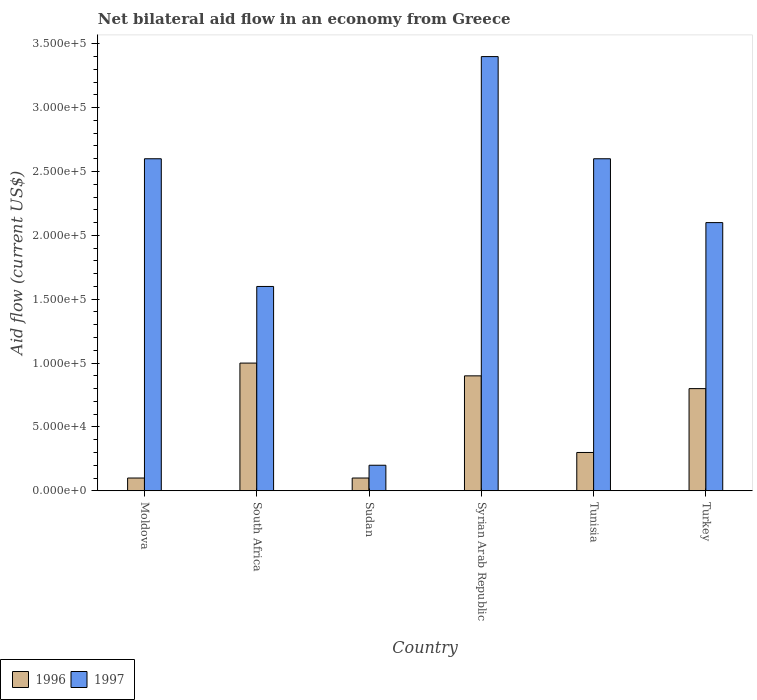How many groups of bars are there?
Your response must be concise. 6. Are the number of bars per tick equal to the number of legend labels?
Keep it short and to the point. Yes. Are the number of bars on each tick of the X-axis equal?
Ensure brevity in your answer.  Yes. How many bars are there on the 3rd tick from the left?
Your answer should be compact. 2. What is the label of the 4th group of bars from the left?
Ensure brevity in your answer.  Syrian Arab Republic. In how many cases, is the number of bars for a given country not equal to the number of legend labels?
Your answer should be compact. 0. In which country was the net bilateral aid flow in 1997 maximum?
Make the answer very short. Syrian Arab Republic. In which country was the net bilateral aid flow in 1997 minimum?
Provide a succinct answer. Sudan. What is the total net bilateral aid flow in 1996 in the graph?
Provide a short and direct response. 3.20e+05. What is the average net bilateral aid flow in 1997 per country?
Offer a terse response. 2.08e+05. In how many countries, is the net bilateral aid flow in 1996 greater than 130000 US$?
Offer a terse response. 0. What is the ratio of the net bilateral aid flow in 1996 in Sudan to that in Tunisia?
Give a very brief answer. 0.33. Is the net bilateral aid flow in 1996 in Sudan less than that in Turkey?
Offer a very short reply. Yes. Is the difference between the net bilateral aid flow in 1996 in South Africa and Syrian Arab Republic greater than the difference between the net bilateral aid flow in 1997 in South Africa and Syrian Arab Republic?
Provide a short and direct response. Yes. What is the difference between the highest and the lowest net bilateral aid flow in 1997?
Keep it short and to the point. 3.20e+05. In how many countries, is the net bilateral aid flow in 1997 greater than the average net bilateral aid flow in 1997 taken over all countries?
Give a very brief answer. 4. Is the sum of the net bilateral aid flow in 1996 in South Africa and Sudan greater than the maximum net bilateral aid flow in 1997 across all countries?
Your answer should be very brief. No. What does the 2nd bar from the left in Moldova represents?
Provide a succinct answer. 1997. How many bars are there?
Your answer should be very brief. 12. Are all the bars in the graph horizontal?
Provide a short and direct response. No. Does the graph contain any zero values?
Your answer should be very brief. No. What is the title of the graph?
Offer a terse response. Net bilateral aid flow in an economy from Greece. Does "2010" appear as one of the legend labels in the graph?
Your response must be concise. No. What is the label or title of the X-axis?
Your response must be concise. Country. What is the label or title of the Y-axis?
Your answer should be compact. Aid flow (current US$). What is the Aid flow (current US$) in 1997 in Moldova?
Your answer should be very brief. 2.60e+05. What is the Aid flow (current US$) in 1997 in Syrian Arab Republic?
Your response must be concise. 3.40e+05. What is the Aid flow (current US$) in 1996 in Tunisia?
Ensure brevity in your answer.  3.00e+04. Across all countries, what is the maximum Aid flow (current US$) in 1996?
Make the answer very short. 1.00e+05. What is the total Aid flow (current US$) of 1997 in the graph?
Provide a succinct answer. 1.25e+06. What is the difference between the Aid flow (current US$) in 1996 in Moldova and that in South Africa?
Make the answer very short. -9.00e+04. What is the difference between the Aid flow (current US$) of 1997 in Moldova and that in Sudan?
Ensure brevity in your answer.  2.40e+05. What is the difference between the Aid flow (current US$) of 1996 in Moldova and that in Syrian Arab Republic?
Make the answer very short. -8.00e+04. What is the difference between the Aid flow (current US$) in 1997 in Moldova and that in Syrian Arab Republic?
Provide a succinct answer. -8.00e+04. What is the difference between the Aid flow (current US$) in 1997 in Moldova and that in Tunisia?
Offer a very short reply. 0. What is the difference between the Aid flow (current US$) in 1996 in Moldova and that in Turkey?
Make the answer very short. -7.00e+04. What is the difference between the Aid flow (current US$) in 1996 in South Africa and that in Sudan?
Ensure brevity in your answer.  9.00e+04. What is the difference between the Aid flow (current US$) in 1996 in South Africa and that in Syrian Arab Republic?
Keep it short and to the point. 10000. What is the difference between the Aid flow (current US$) in 1997 in South Africa and that in Syrian Arab Republic?
Provide a succinct answer. -1.80e+05. What is the difference between the Aid flow (current US$) of 1997 in South Africa and that in Turkey?
Your answer should be very brief. -5.00e+04. What is the difference between the Aid flow (current US$) of 1996 in Sudan and that in Syrian Arab Republic?
Provide a succinct answer. -8.00e+04. What is the difference between the Aid flow (current US$) in 1997 in Sudan and that in Syrian Arab Republic?
Offer a very short reply. -3.20e+05. What is the difference between the Aid flow (current US$) in 1996 in Sudan and that in Tunisia?
Provide a short and direct response. -2.00e+04. What is the difference between the Aid flow (current US$) in 1996 in Sudan and that in Turkey?
Keep it short and to the point. -7.00e+04. What is the difference between the Aid flow (current US$) of 1996 in Syrian Arab Republic and that in Tunisia?
Make the answer very short. 6.00e+04. What is the difference between the Aid flow (current US$) in 1997 in Syrian Arab Republic and that in Tunisia?
Offer a terse response. 8.00e+04. What is the difference between the Aid flow (current US$) in 1997 in Syrian Arab Republic and that in Turkey?
Offer a very short reply. 1.30e+05. What is the difference between the Aid flow (current US$) in 1996 in Moldova and the Aid flow (current US$) in 1997 in Sudan?
Make the answer very short. -10000. What is the difference between the Aid flow (current US$) of 1996 in Moldova and the Aid flow (current US$) of 1997 in Syrian Arab Republic?
Give a very brief answer. -3.30e+05. What is the difference between the Aid flow (current US$) of 1996 in Moldova and the Aid flow (current US$) of 1997 in Tunisia?
Make the answer very short. -2.50e+05. What is the difference between the Aid flow (current US$) in 1996 in Moldova and the Aid flow (current US$) in 1997 in Turkey?
Your answer should be compact. -2.00e+05. What is the difference between the Aid flow (current US$) in 1996 in South Africa and the Aid flow (current US$) in 1997 in Syrian Arab Republic?
Your answer should be compact. -2.40e+05. What is the difference between the Aid flow (current US$) of 1996 in South Africa and the Aid flow (current US$) of 1997 in Tunisia?
Give a very brief answer. -1.60e+05. What is the difference between the Aid flow (current US$) of 1996 in Sudan and the Aid flow (current US$) of 1997 in Syrian Arab Republic?
Give a very brief answer. -3.30e+05. What is the difference between the Aid flow (current US$) in 1996 in Sudan and the Aid flow (current US$) in 1997 in Tunisia?
Give a very brief answer. -2.50e+05. What is the difference between the Aid flow (current US$) of 1996 in Sudan and the Aid flow (current US$) of 1997 in Turkey?
Give a very brief answer. -2.00e+05. What is the difference between the Aid flow (current US$) in 1996 in Syrian Arab Republic and the Aid flow (current US$) in 1997 in Tunisia?
Make the answer very short. -1.70e+05. What is the difference between the Aid flow (current US$) of 1996 in Tunisia and the Aid flow (current US$) of 1997 in Turkey?
Ensure brevity in your answer.  -1.80e+05. What is the average Aid flow (current US$) in 1996 per country?
Keep it short and to the point. 5.33e+04. What is the average Aid flow (current US$) of 1997 per country?
Offer a very short reply. 2.08e+05. What is the difference between the Aid flow (current US$) of 1996 and Aid flow (current US$) of 1997 in South Africa?
Your answer should be very brief. -6.00e+04. What is the difference between the Aid flow (current US$) of 1996 and Aid flow (current US$) of 1997 in Sudan?
Ensure brevity in your answer.  -10000. What is the difference between the Aid flow (current US$) of 1996 and Aid flow (current US$) of 1997 in Tunisia?
Your response must be concise. -2.30e+05. What is the difference between the Aid flow (current US$) of 1996 and Aid flow (current US$) of 1997 in Turkey?
Give a very brief answer. -1.30e+05. What is the ratio of the Aid flow (current US$) in 1996 in Moldova to that in South Africa?
Your answer should be very brief. 0.1. What is the ratio of the Aid flow (current US$) in 1997 in Moldova to that in South Africa?
Your answer should be very brief. 1.62. What is the ratio of the Aid flow (current US$) in 1997 in Moldova to that in Syrian Arab Republic?
Make the answer very short. 0.76. What is the ratio of the Aid flow (current US$) in 1996 in Moldova to that in Tunisia?
Give a very brief answer. 0.33. What is the ratio of the Aid flow (current US$) of 1997 in Moldova to that in Tunisia?
Ensure brevity in your answer.  1. What is the ratio of the Aid flow (current US$) of 1996 in Moldova to that in Turkey?
Ensure brevity in your answer.  0.12. What is the ratio of the Aid flow (current US$) in 1997 in Moldova to that in Turkey?
Offer a very short reply. 1.24. What is the ratio of the Aid flow (current US$) of 1996 in South Africa to that in Syrian Arab Republic?
Provide a succinct answer. 1.11. What is the ratio of the Aid flow (current US$) of 1997 in South Africa to that in Syrian Arab Republic?
Give a very brief answer. 0.47. What is the ratio of the Aid flow (current US$) in 1997 in South Africa to that in Tunisia?
Ensure brevity in your answer.  0.62. What is the ratio of the Aid flow (current US$) in 1996 in South Africa to that in Turkey?
Your answer should be very brief. 1.25. What is the ratio of the Aid flow (current US$) of 1997 in South Africa to that in Turkey?
Your answer should be compact. 0.76. What is the ratio of the Aid flow (current US$) of 1997 in Sudan to that in Syrian Arab Republic?
Give a very brief answer. 0.06. What is the ratio of the Aid flow (current US$) of 1996 in Sudan to that in Tunisia?
Your answer should be compact. 0.33. What is the ratio of the Aid flow (current US$) in 1997 in Sudan to that in Tunisia?
Give a very brief answer. 0.08. What is the ratio of the Aid flow (current US$) in 1997 in Sudan to that in Turkey?
Provide a short and direct response. 0.1. What is the ratio of the Aid flow (current US$) in 1997 in Syrian Arab Republic to that in Tunisia?
Offer a terse response. 1.31. What is the ratio of the Aid flow (current US$) in 1997 in Syrian Arab Republic to that in Turkey?
Ensure brevity in your answer.  1.62. What is the ratio of the Aid flow (current US$) in 1997 in Tunisia to that in Turkey?
Make the answer very short. 1.24. What is the difference between the highest and the second highest Aid flow (current US$) of 1996?
Offer a terse response. 10000. What is the difference between the highest and the second highest Aid flow (current US$) in 1997?
Provide a short and direct response. 8.00e+04. 